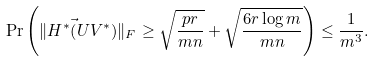<formula> <loc_0><loc_0><loc_500><loc_500>\Pr \left ( \| H ^ { * } \vec { ( } U V ^ { * } ) \| _ { F } \geq \sqrt { \frac { p r } { m n } } + \sqrt { \frac { 6 r \log m } { m n } } \right ) \leq \frac { 1 } { m ^ { 3 } } .</formula> 